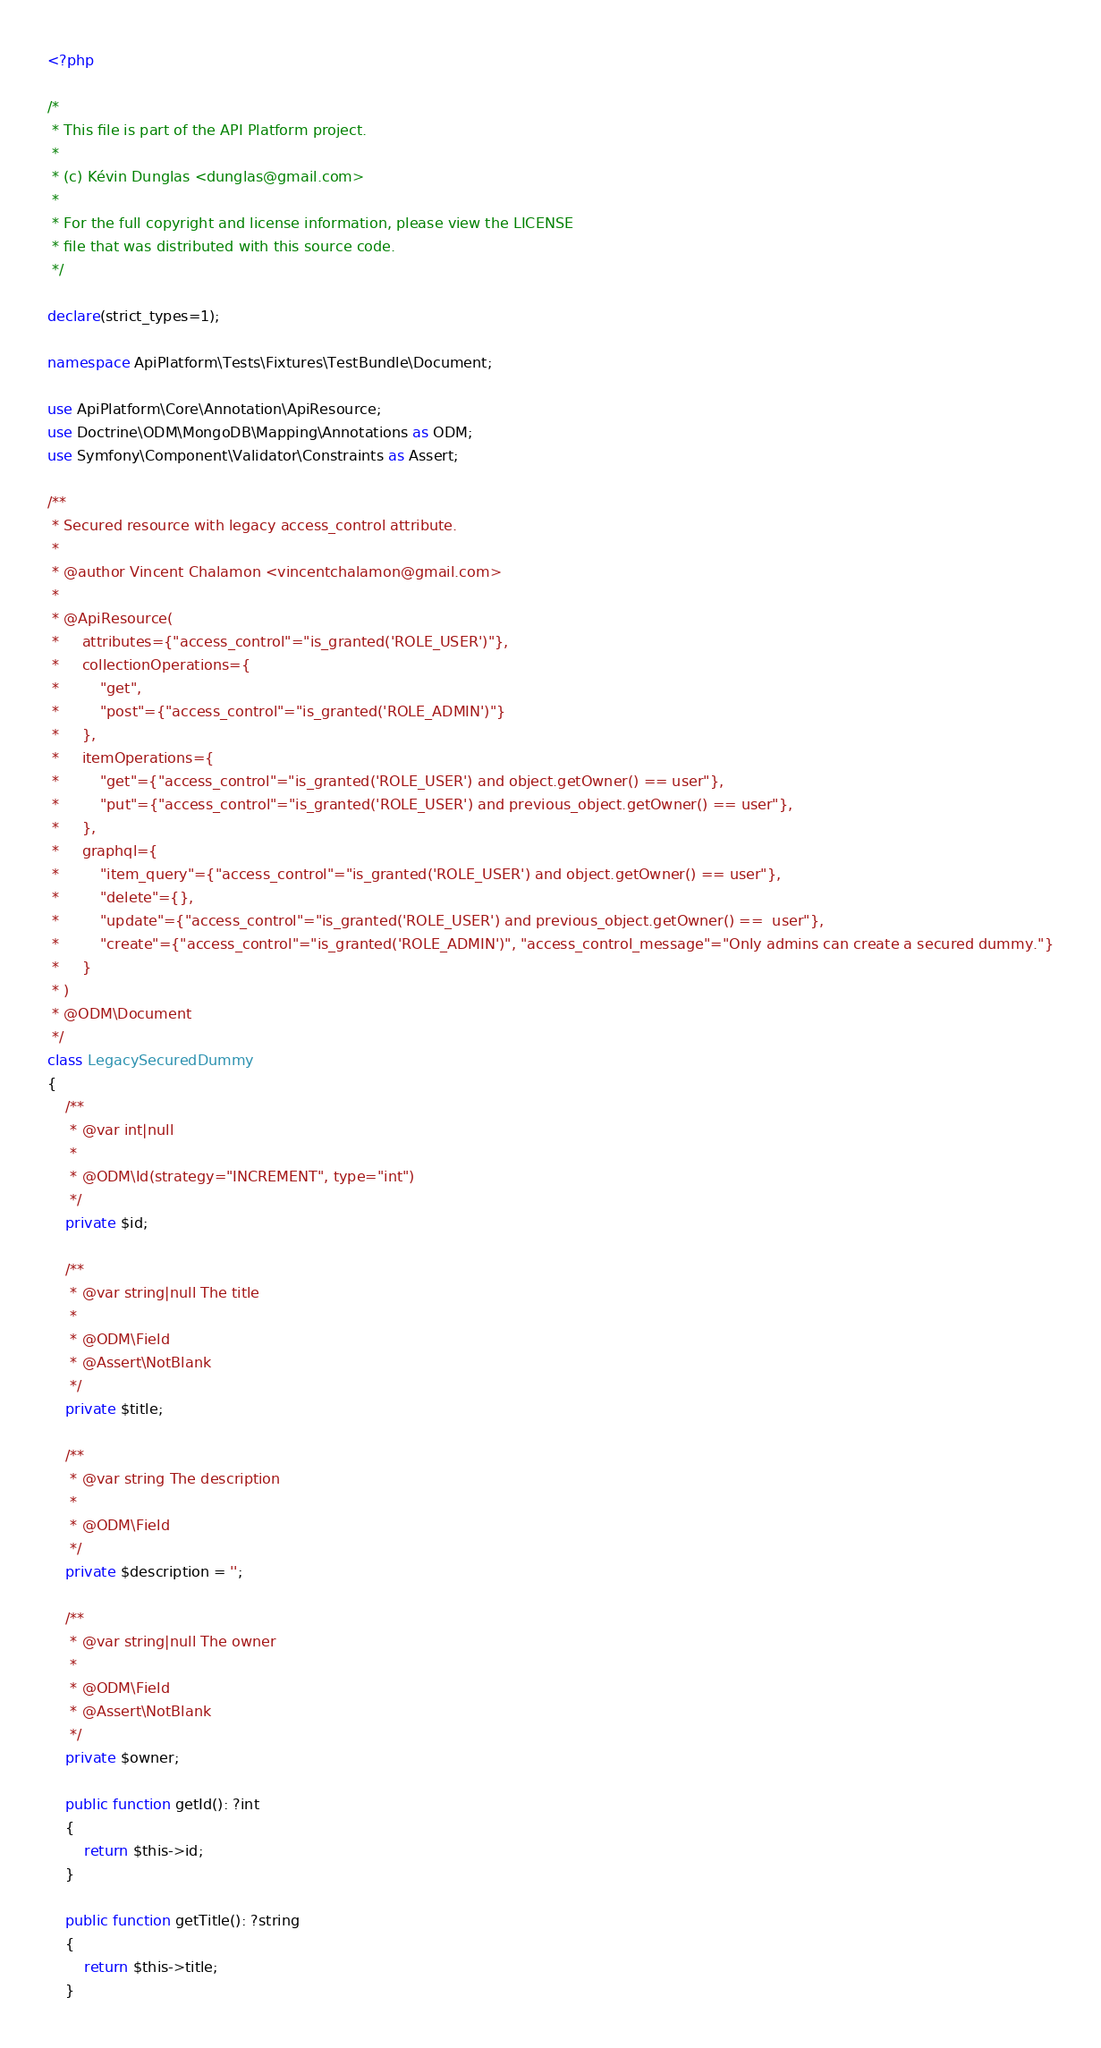<code> <loc_0><loc_0><loc_500><loc_500><_PHP_><?php

/*
 * This file is part of the API Platform project.
 *
 * (c) Kévin Dunglas <dunglas@gmail.com>
 *
 * For the full copyright and license information, please view the LICENSE
 * file that was distributed with this source code.
 */

declare(strict_types=1);

namespace ApiPlatform\Tests\Fixtures\TestBundle\Document;

use ApiPlatform\Core\Annotation\ApiResource;
use Doctrine\ODM\MongoDB\Mapping\Annotations as ODM;
use Symfony\Component\Validator\Constraints as Assert;

/**
 * Secured resource with legacy access_control attribute.
 *
 * @author Vincent Chalamon <vincentchalamon@gmail.com>
 *
 * @ApiResource(
 *     attributes={"access_control"="is_granted('ROLE_USER')"},
 *     collectionOperations={
 *         "get",
 *         "post"={"access_control"="is_granted('ROLE_ADMIN')"}
 *     },
 *     itemOperations={
 *         "get"={"access_control"="is_granted('ROLE_USER') and object.getOwner() == user"},
 *         "put"={"access_control"="is_granted('ROLE_USER') and previous_object.getOwner() == user"},
 *     },
 *     graphql={
 *         "item_query"={"access_control"="is_granted('ROLE_USER') and object.getOwner() == user"},
 *         "delete"={},
 *         "update"={"access_control"="is_granted('ROLE_USER') and previous_object.getOwner() ==  user"},
 *         "create"={"access_control"="is_granted('ROLE_ADMIN')", "access_control_message"="Only admins can create a secured dummy."}
 *     }
 * )
 * @ODM\Document
 */
class LegacySecuredDummy
{
    /**
     * @var int|null
     *
     * @ODM\Id(strategy="INCREMENT", type="int")
     */
    private $id;

    /**
     * @var string|null The title
     *
     * @ODM\Field
     * @Assert\NotBlank
     */
    private $title;

    /**
     * @var string The description
     *
     * @ODM\Field
     */
    private $description = '';

    /**
     * @var string|null The owner
     *
     * @ODM\Field
     * @Assert\NotBlank
     */
    private $owner;

    public function getId(): ?int
    {
        return $this->id;
    }

    public function getTitle(): ?string
    {
        return $this->title;
    }
</code> 